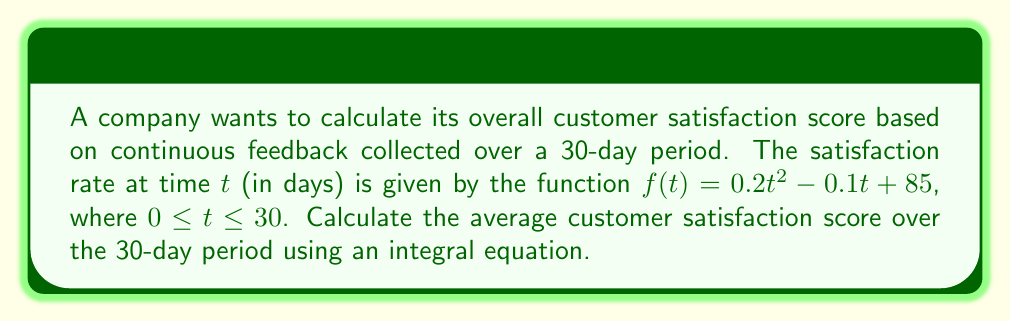Provide a solution to this math problem. To solve this problem, we need to follow these steps:

1) The average value of a function over an interval can be calculated using the definite integral:

   $$ \text{Average} = \frac{1}{b-a} \int_{a}^{b} f(t) dt $$

   where $a$ and $b$ are the start and end points of the interval.

2) In this case, $a = 0$, $b = 30$, and $f(t) = 0.2t^2 - 0.1t + 85$. Let's substitute these into the formula:

   $$ \text{Average} = \frac{1}{30-0} \int_{0}^{30} (0.2t^2 - 0.1t + 85) dt $$

3) Simplify:

   $$ \text{Average} = \frac{1}{30} \int_{0}^{30} (0.2t^2 - 0.1t + 85) dt $$

4) Now, let's solve the integral:

   $$ \int_{0}^{30} (0.2t^2 - 0.1t + 85) dt = \left[\frac{0.2t^3}{3} - \frac{0.1t^2}{2} + 85t\right]_{0}^{30} $$

5) Evaluate the integral:

   $$ = \left(\frac{0.2(30^3)}{3} - \frac{0.1(30^2)}{2} + 85(30)\right) - \left(\frac{0.2(0^3)}{3} - \frac{0.1(0^2)}{2} + 85(0)\right) $$

6) Simplify:

   $$ = (1800 - 45 + 2550) - 0 = 4305 $$

7) Finally, divide by 30 to get the average:

   $$ \text{Average} = \frac{4305}{30} = 143.5 $$

Therefore, the average customer satisfaction score over the 30-day period is 143.5.
Answer: 143.5 